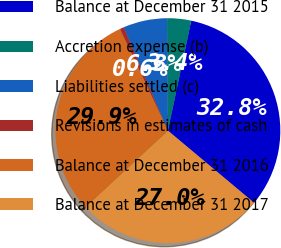Convert chart to OTSL. <chart><loc_0><loc_0><loc_500><loc_500><pie_chart><fcel>Balance at December 31 2015<fcel>Accretion expense (b)<fcel>Liabilities settled (c)<fcel>Revisions in estimates of cash<fcel>Balance at December 31 2016<fcel>Balance at December 31 2017<nl><fcel>32.76%<fcel>3.45%<fcel>6.32%<fcel>0.58%<fcel>29.88%<fcel>27.01%<nl></chart> 